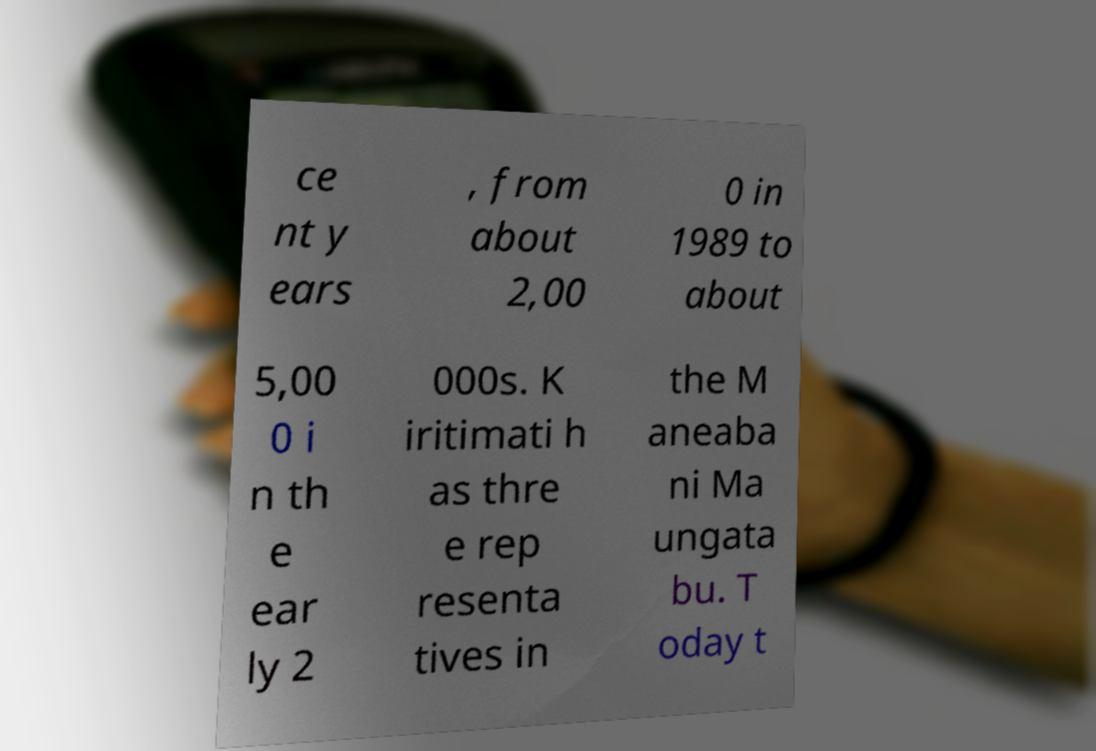Can you read and provide the text displayed in the image?This photo seems to have some interesting text. Can you extract and type it out for me? ce nt y ears , from about 2,00 0 in 1989 to about 5,00 0 i n th e ear ly 2 000s. K iritimati h as thre e rep resenta tives in the M aneaba ni Ma ungata bu. T oday t 